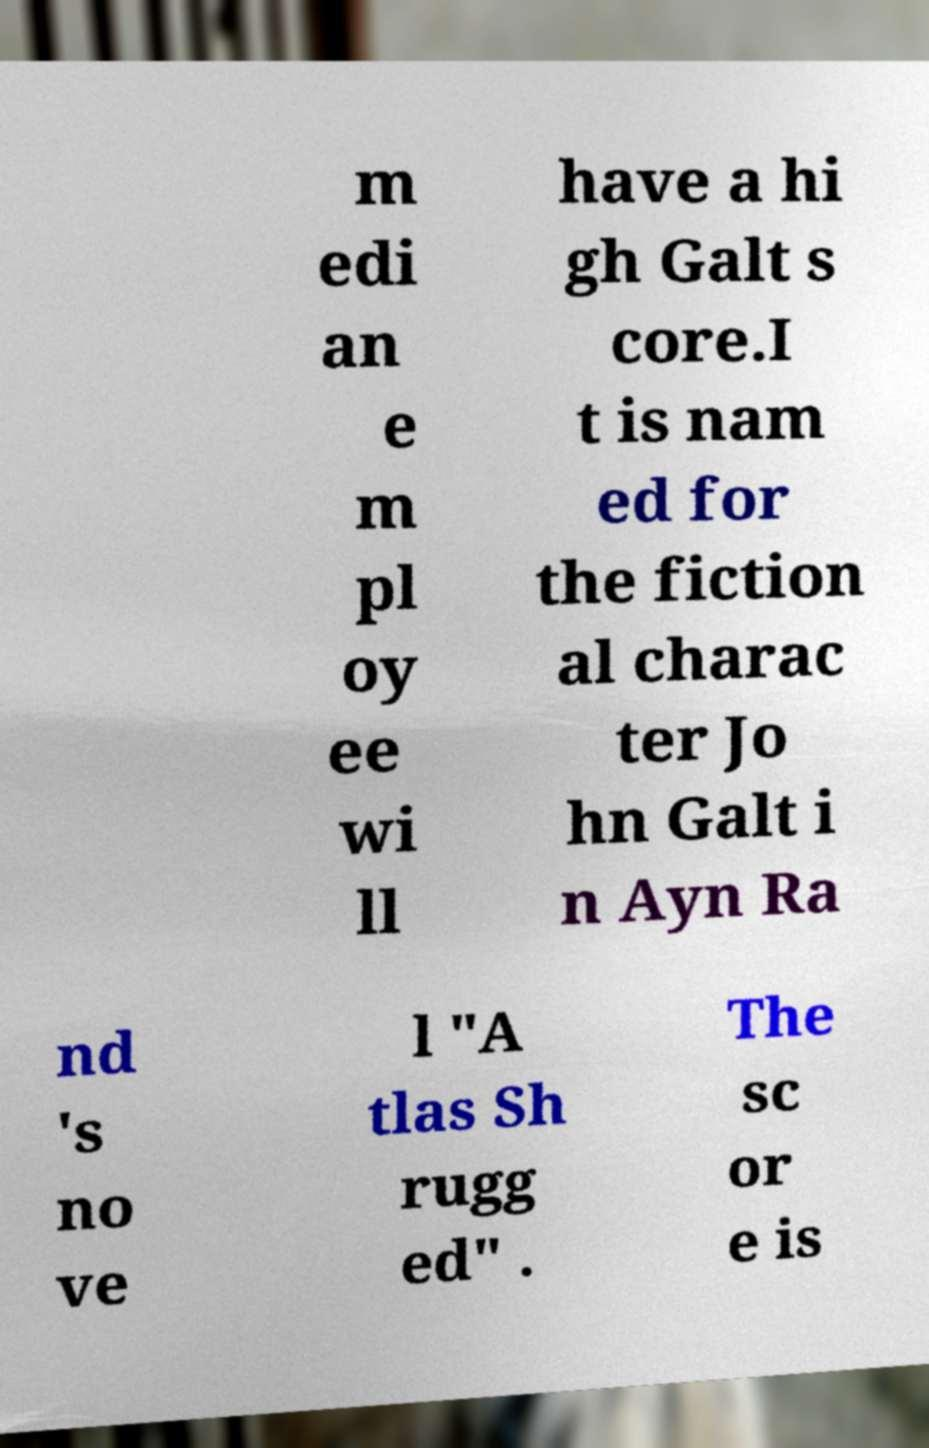What messages or text are displayed in this image? I need them in a readable, typed format. m edi an e m pl oy ee wi ll have a hi gh Galt s core.I t is nam ed for the fiction al charac ter Jo hn Galt i n Ayn Ra nd 's no ve l "A tlas Sh rugg ed" . The sc or e is 